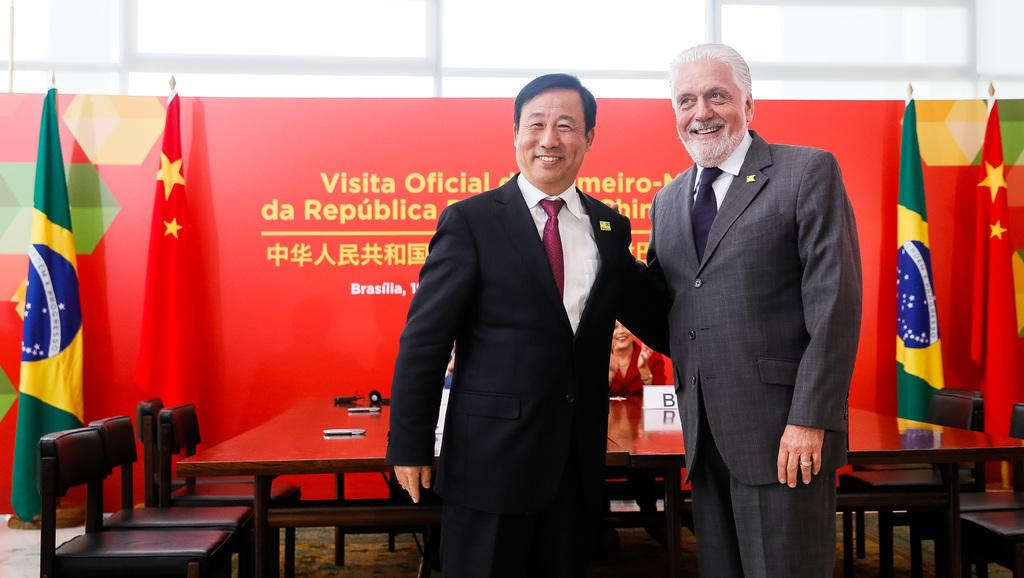How many people are standing in the image? There are two persons standing in the image. What furniture is present in the image? There is a table and chairs in the image. What can be seen flying or waving in the image? There is a flag in the image. What type of advertising or promotional material is present in the image? There is a hoarding in the image. What is the position of the woman in the image? There is a woman sitting on a chair in the image. What type of metal is used to make the seed in the image? There is no seed or metal present in the image. What kind of flowers are growing on the woman's chair in the image? There are no flowers present on the woman's chair in the image. 